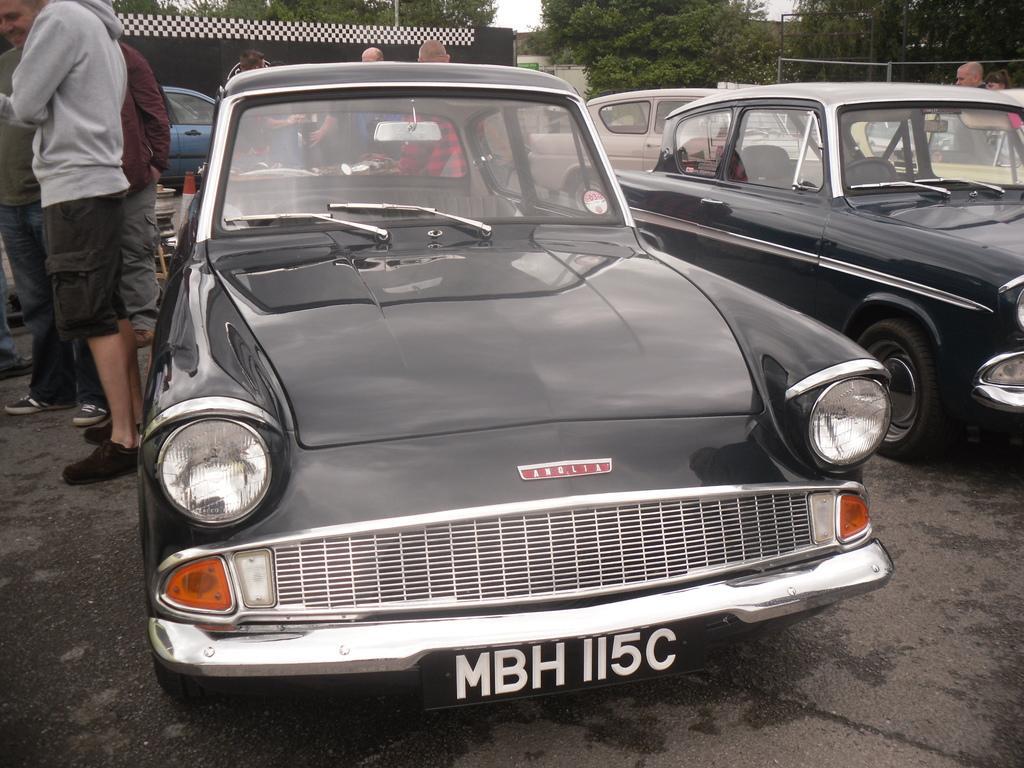How would you summarize this image in a sentence or two? This picture shows few cars and we see few people are standing and we see trees and a house. 